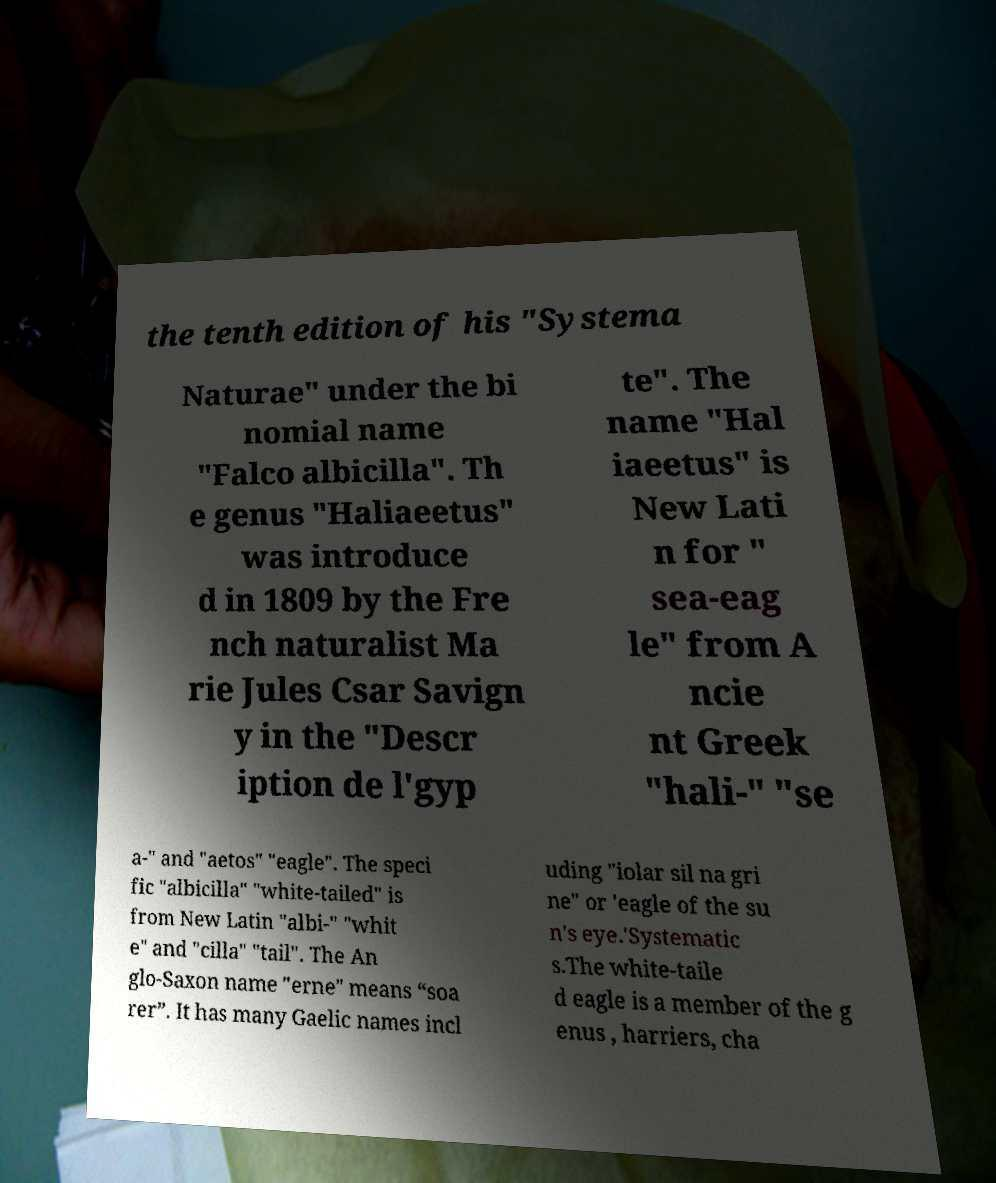For documentation purposes, I need the text within this image transcribed. Could you provide that? the tenth edition of his "Systema Naturae" under the bi nomial name "Falco albicilla". Th e genus "Haliaeetus" was introduce d in 1809 by the Fre nch naturalist Ma rie Jules Csar Savign y in the "Descr iption de l'gyp te". The name "Hal iaeetus" is New Lati n for " sea-eag le" from A ncie nt Greek "hali-" "se a-" and "aetos" "eagle". The speci fic "albicilla" "white-tailed" is from New Latin "albi-" "whit e" and "cilla" "tail". The An glo-Saxon name "erne" means “soa rer”. It has many Gaelic names incl uding "iolar sil na gri ne" or 'eagle of the su n's eye.'Systematic s.The white-taile d eagle is a member of the g enus , harriers, cha 